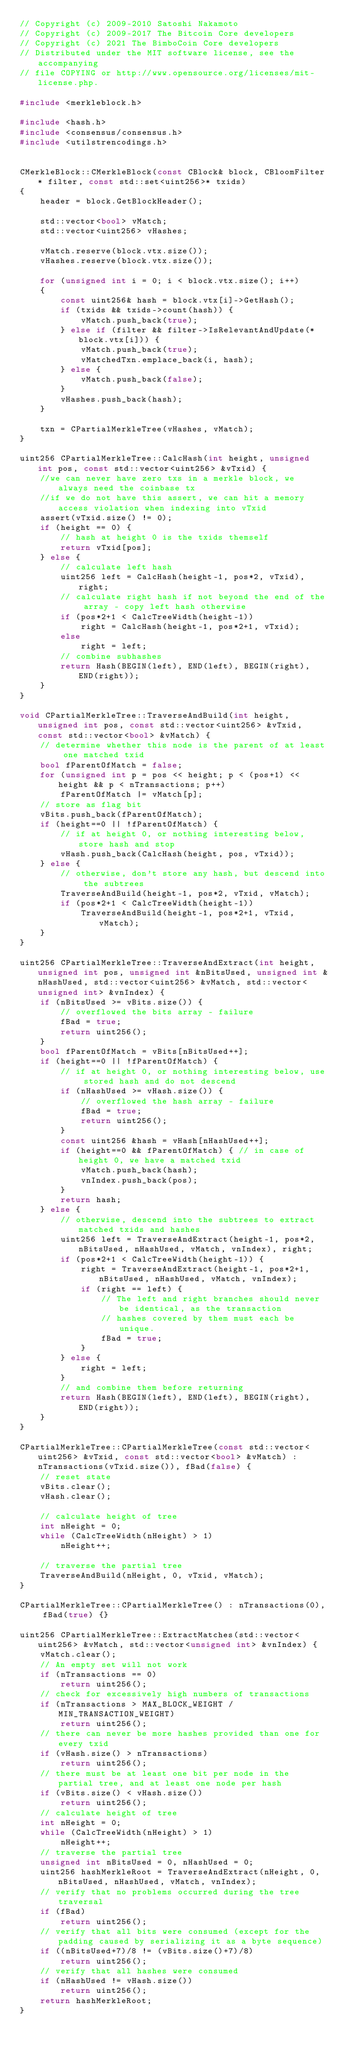Convert code to text. <code><loc_0><loc_0><loc_500><loc_500><_C++_>// Copyright (c) 2009-2010 Satoshi Nakamoto
// Copyright (c) 2009-2017 The Bitcoin Core developers
// Copyright (c) 2021 The BimboCoin Core developers
// Distributed under the MIT software license, see the accompanying
// file COPYING or http://www.opensource.org/licenses/mit-license.php.

#include <merkleblock.h>

#include <hash.h>
#include <consensus/consensus.h>
#include <utilstrencodings.h>


CMerkleBlock::CMerkleBlock(const CBlock& block, CBloomFilter* filter, const std::set<uint256>* txids)
{
    header = block.GetBlockHeader();

    std::vector<bool> vMatch;
    std::vector<uint256> vHashes;

    vMatch.reserve(block.vtx.size());
    vHashes.reserve(block.vtx.size());

    for (unsigned int i = 0; i < block.vtx.size(); i++)
    {
        const uint256& hash = block.vtx[i]->GetHash();
        if (txids && txids->count(hash)) {
            vMatch.push_back(true);
        } else if (filter && filter->IsRelevantAndUpdate(*block.vtx[i])) {
            vMatch.push_back(true);
            vMatchedTxn.emplace_back(i, hash);
        } else {
            vMatch.push_back(false);
        }
        vHashes.push_back(hash);
    }

    txn = CPartialMerkleTree(vHashes, vMatch);
}

uint256 CPartialMerkleTree::CalcHash(int height, unsigned int pos, const std::vector<uint256> &vTxid) {
    //we can never have zero txs in a merkle block, we always need the coinbase tx
    //if we do not have this assert, we can hit a memory access violation when indexing into vTxid
    assert(vTxid.size() != 0);
    if (height == 0) {
        // hash at height 0 is the txids themself
        return vTxid[pos];
    } else {
        // calculate left hash
        uint256 left = CalcHash(height-1, pos*2, vTxid), right;
        // calculate right hash if not beyond the end of the array - copy left hash otherwise
        if (pos*2+1 < CalcTreeWidth(height-1))
            right = CalcHash(height-1, pos*2+1, vTxid);
        else
            right = left;
        // combine subhashes
        return Hash(BEGIN(left), END(left), BEGIN(right), END(right));
    }
}

void CPartialMerkleTree::TraverseAndBuild(int height, unsigned int pos, const std::vector<uint256> &vTxid, const std::vector<bool> &vMatch) {
    // determine whether this node is the parent of at least one matched txid
    bool fParentOfMatch = false;
    for (unsigned int p = pos << height; p < (pos+1) << height && p < nTransactions; p++)
        fParentOfMatch |= vMatch[p];
    // store as flag bit
    vBits.push_back(fParentOfMatch);
    if (height==0 || !fParentOfMatch) {
        // if at height 0, or nothing interesting below, store hash and stop
        vHash.push_back(CalcHash(height, pos, vTxid));
    } else {
        // otherwise, don't store any hash, but descend into the subtrees
        TraverseAndBuild(height-1, pos*2, vTxid, vMatch);
        if (pos*2+1 < CalcTreeWidth(height-1))
            TraverseAndBuild(height-1, pos*2+1, vTxid, vMatch);
    }
}

uint256 CPartialMerkleTree::TraverseAndExtract(int height, unsigned int pos, unsigned int &nBitsUsed, unsigned int &nHashUsed, std::vector<uint256> &vMatch, std::vector<unsigned int> &vnIndex) {
    if (nBitsUsed >= vBits.size()) {
        // overflowed the bits array - failure
        fBad = true;
        return uint256();
    }
    bool fParentOfMatch = vBits[nBitsUsed++];
    if (height==0 || !fParentOfMatch) {
        // if at height 0, or nothing interesting below, use stored hash and do not descend
        if (nHashUsed >= vHash.size()) {
            // overflowed the hash array - failure
            fBad = true;
            return uint256();
        }
        const uint256 &hash = vHash[nHashUsed++];
        if (height==0 && fParentOfMatch) { // in case of height 0, we have a matched txid
            vMatch.push_back(hash);
            vnIndex.push_back(pos);
        }
        return hash;
    } else {
        // otherwise, descend into the subtrees to extract matched txids and hashes
        uint256 left = TraverseAndExtract(height-1, pos*2, nBitsUsed, nHashUsed, vMatch, vnIndex), right;
        if (pos*2+1 < CalcTreeWidth(height-1)) {
            right = TraverseAndExtract(height-1, pos*2+1, nBitsUsed, nHashUsed, vMatch, vnIndex);
            if (right == left) {
                // The left and right branches should never be identical, as the transaction
                // hashes covered by them must each be unique.
                fBad = true;
            }
        } else {
            right = left;
        }
        // and combine them before returning
        return Hash(BEGIN(left), END(left), BEGIN(right), END(right));
    }
}

CPartialMerkleTree::CPartialMerkleTree(const std::vector<uint256> &vTxid, const std::vector<bool> &vMatch) : nTransactions(vTxid.size()), fBad(false) {
    // reset state
    vBits.clear();
    vHash.clear();

    // calculate height of tree
    int nHeight = 0;
    while (CalcTreeWidth(nHeight) > 1)
        nHeight++;

    // traverse the partial tree
    TraverseAndBuild(nHeight, 0, vTxid, vMatch);
}

CPartialMerkleTree::CPartialMerkleTree() : nTransactions(0), fBad(true) {}

uint256 CPartialMerkleTree::ExtractMatches(std::vector<uint256> &vMatch, std::vector<unsigned int> &vnIndex) {
    vMatch.clear();
    // An empty set will not work
    if (nTransactions == 0)
        return uint256();
    // check for excessively high numbers of transactions
    if (nTransactions > MAX_BLOCK_WEIGHT / MIN_TRANSACTION_WEIGHT)
        return uint256();
    // there can never be more hashes provided than one for every txid
    if (vHash.size() > nTransactions)
        return uint256();
    // there must be at least one bit per node in the partial tree, and at least one node per hash
    if (vBits.size() < vHash.size())
        return uint256();
    // calculate height of tree
    int nHeight = 0;
    while (CalcTreeWidth(nHeight) > 1)
        nHeight++;
    // traverse the partial tree
    unsigned int nBitsUsed = 0, nHashUsed = 0;
    uint256 hashMerkleRoot = TraverseAndExtract(nHeight, 0, nBitsUsed, nHashUsed, vMatch, vnIndex);
    // verify that no problems occurred during the tree traversal
    if (fBad)
        return uint256();
    // verify that all bits were consumed (except for the padding caused by serializing it as a byte sequence)
    if ((nBitsUsed+7)/8 != (vBits.size()+7)/8)
        return uint256();
    // verify that all hashes were consumed
    if (nHashUsed != vHash.size())
        return uint256();
    return hashMerkleRoot;
}
</code> 